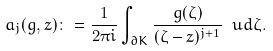<formula> <loc_0><loc_0><loc_500><loc_500>a _ { j } ( g , z ) \colon = \frac { 1 } { 2 \pi i } \int _ { \partial K } \frac { g ( \zeta ) } { ( \zeta - z ) ^ { j + 1 } } \ u d \zeta .</formula> 